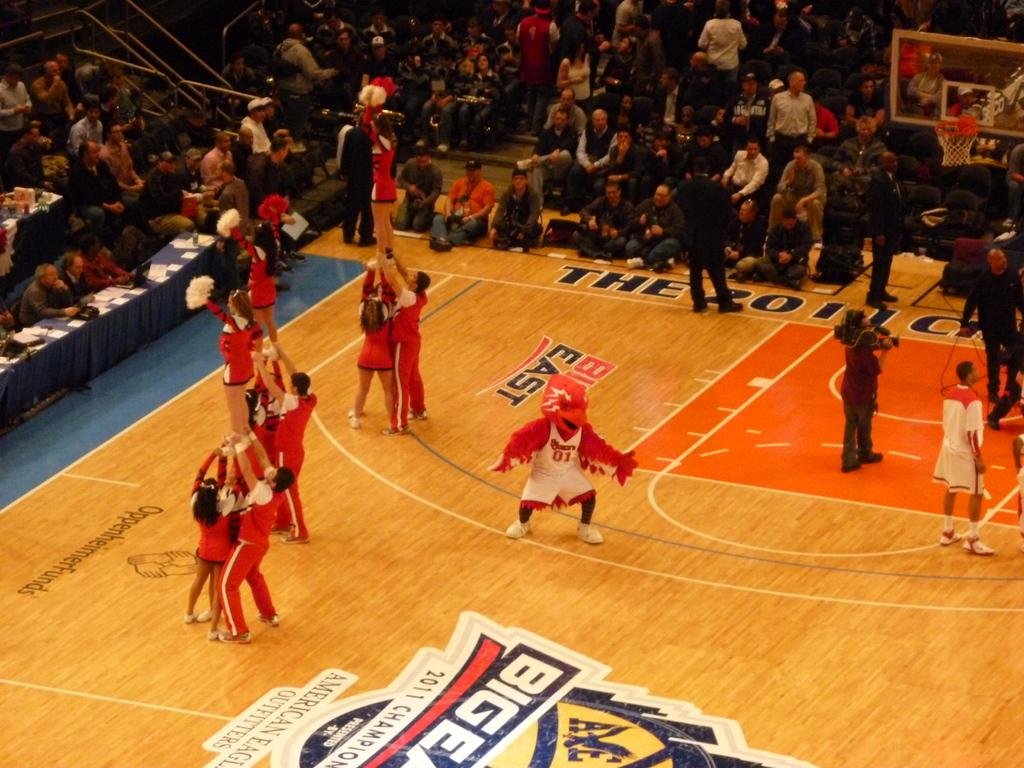What are the persons in the image doing? The persons in the image are on the floor. What type of furniture is present in the image? There are tables in the image. What material is visible in the image? There is cloth visible in the image. What type of objects can be seen on the tables? There are papers in the image. What sports equipment is present in the image? There is a basketball goal in the image. What can be seen in the background of the image? There is a crowd in the background of the image. How many holes are visible in the image? There are no holes mentioned or visible in the image. What type of paper is being used by the persons in the image? The provided facts do not specify the type of paper in the image. 